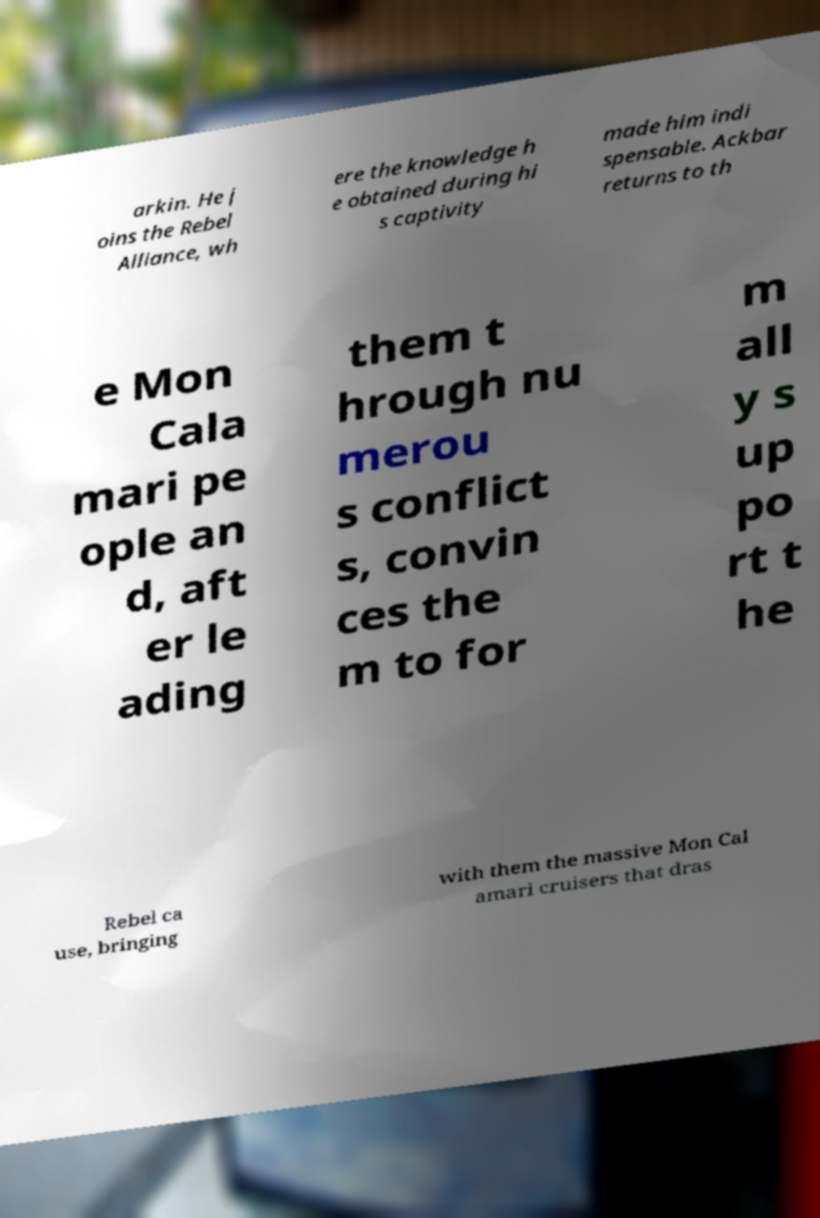Can you accurately transcribe the text from the provided image for me? arkin. He j oins the Rebel Alliance, wh ere the knowledge h e obtained during hi s captivity made him indi spensable. Ackbar returns to th e Mon Cala mari pe ople an d, aft er le ading them t hrough nu merou s conflict s, convin ces the m to for m all y s up po rt t he Rebel ca use, bringing with them the massive Mon Cal amari cruisers that dras 